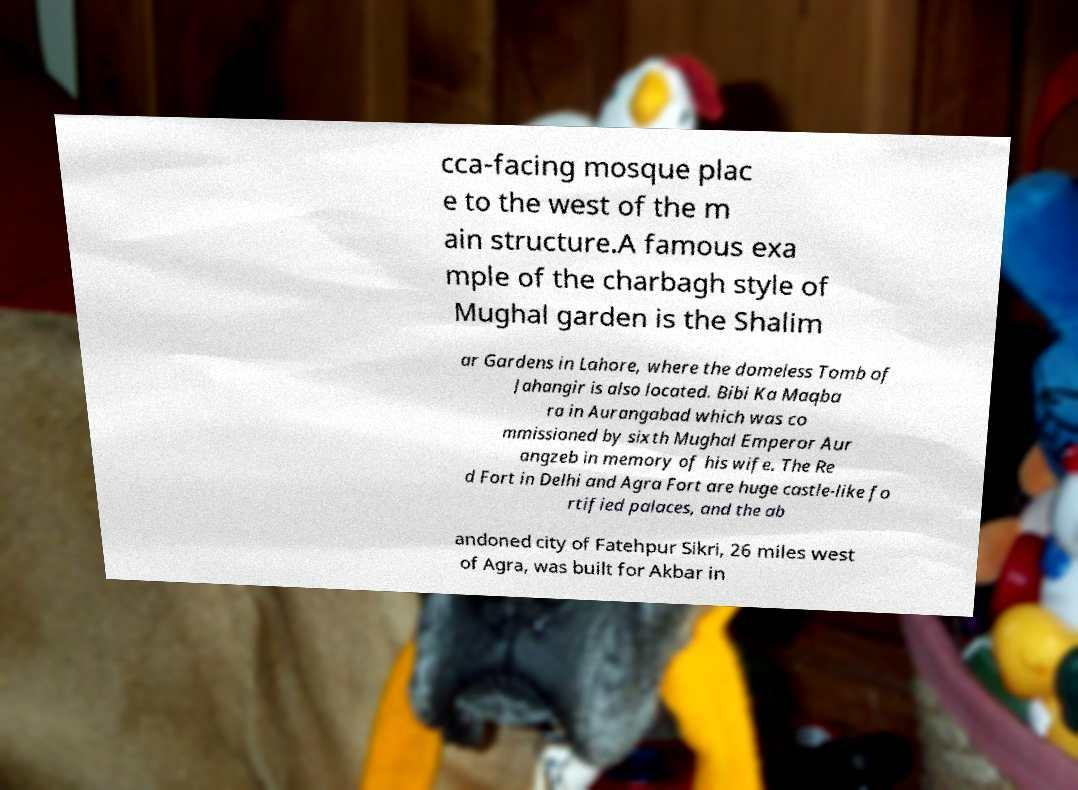There's text embedded in this image that I need extracted. Can you transcribe it verbatim? cca-facing mosque plac e to the west of the m ain structure.A famous exa mple of the charbagh style of Mughal garden is the Shalim ar Gardens in Lahore, where the domeless Tomb of Jahangir is also located. Bibi Ka Maqba ra in Aurangabad which was co mmissioned by sixth Mughal Emperor Aur angzeb in memory of his wife. The Re d Fort in Delhi and Agra Fort are huge castle-like fo rtified palaces, and the ab andoned city of Fatehpur Sikri, 26 miles west of Agra, was built for Akbar in 